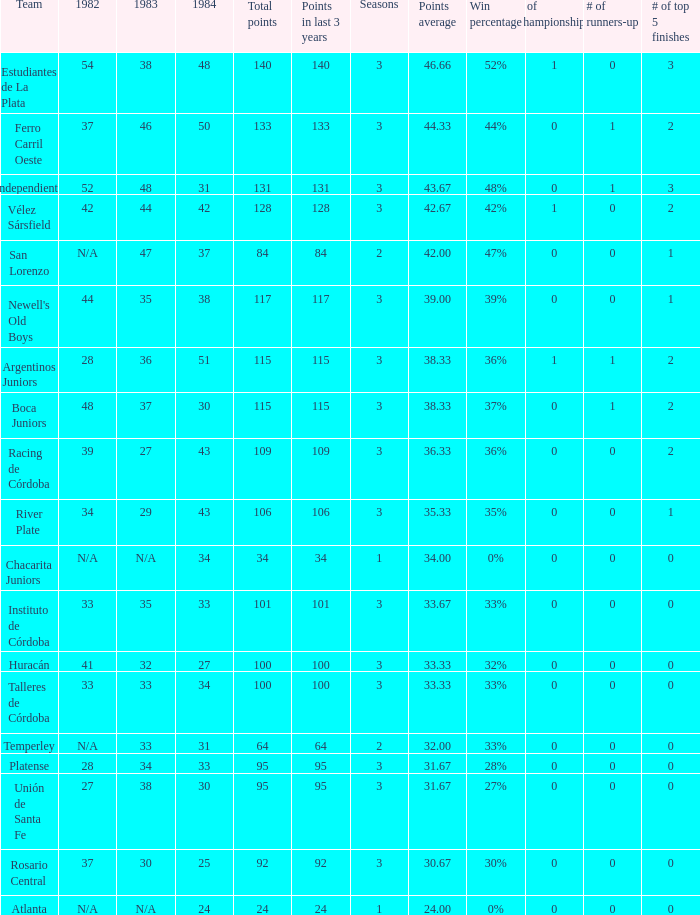What team had 3 seasons and fewer than 27 in 1984? Rosario Central. 